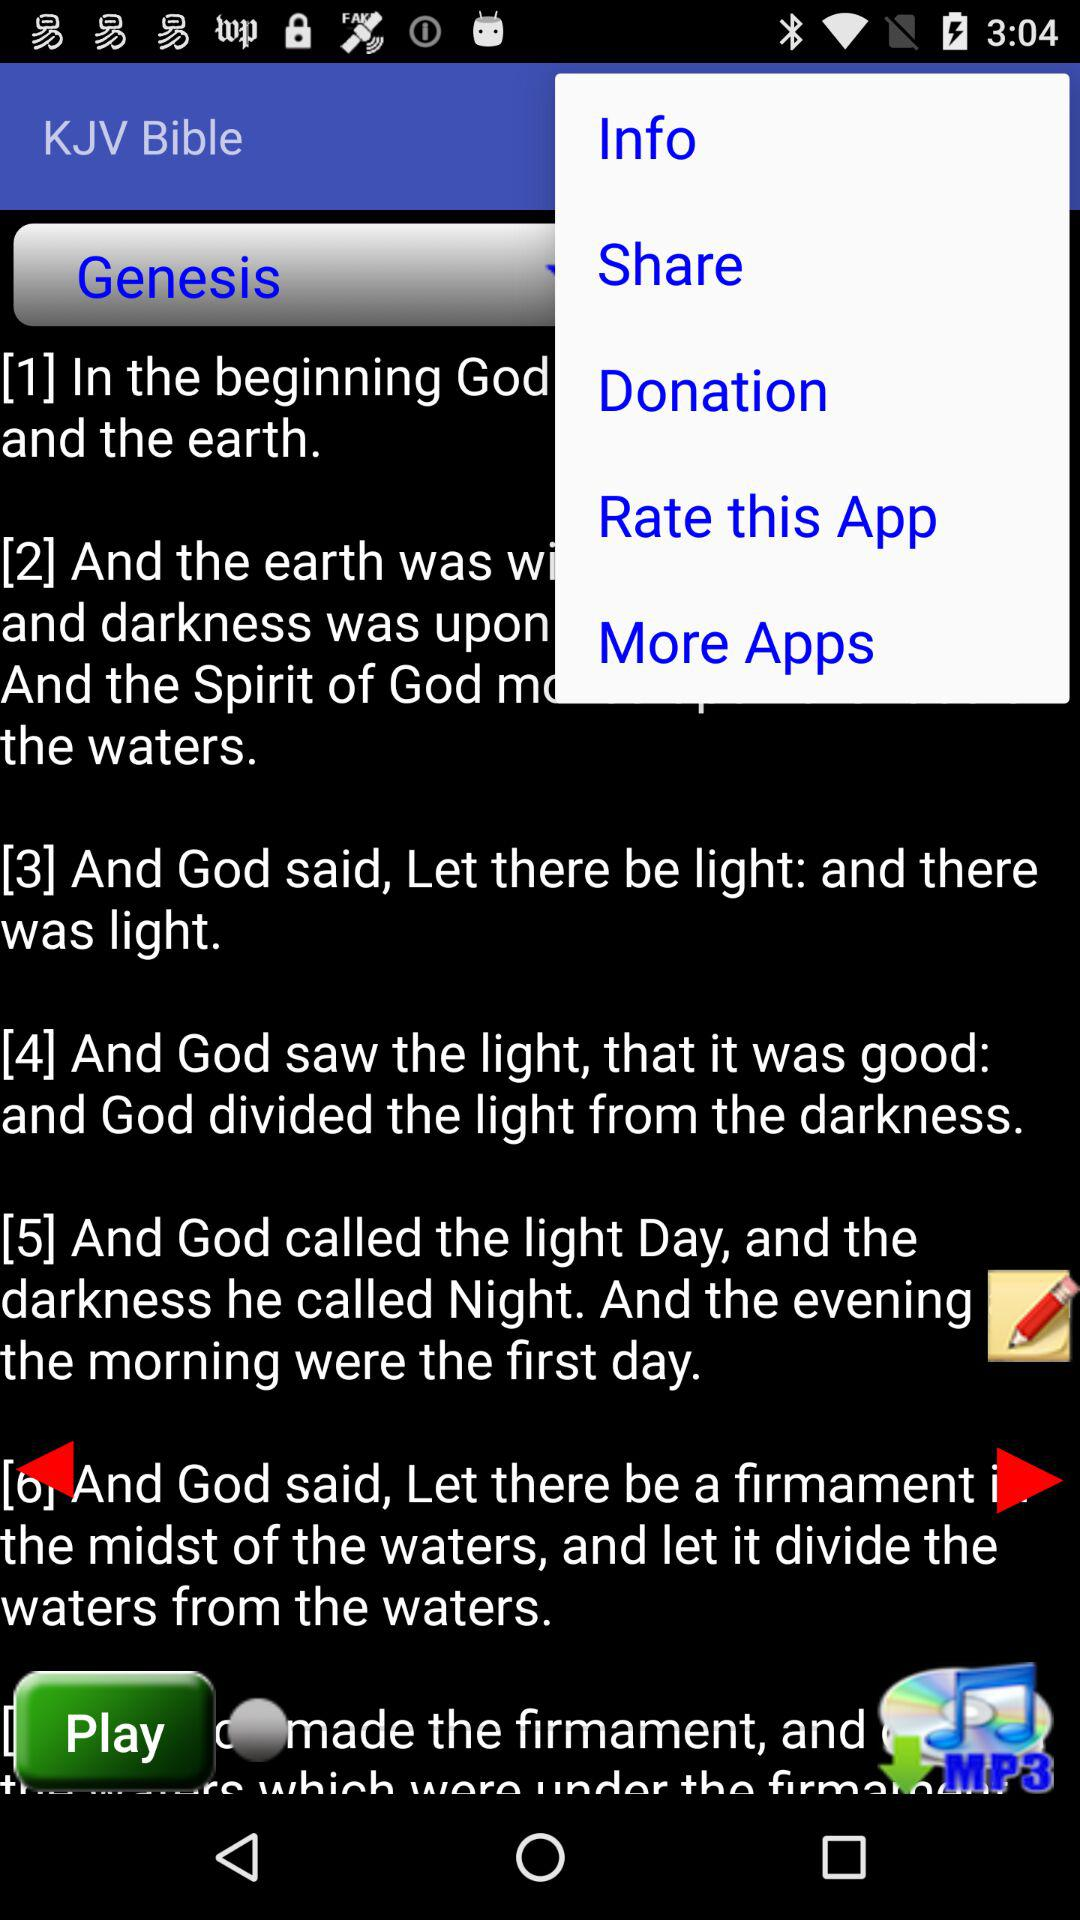What is the application name? The application name is "KJV Bible". 